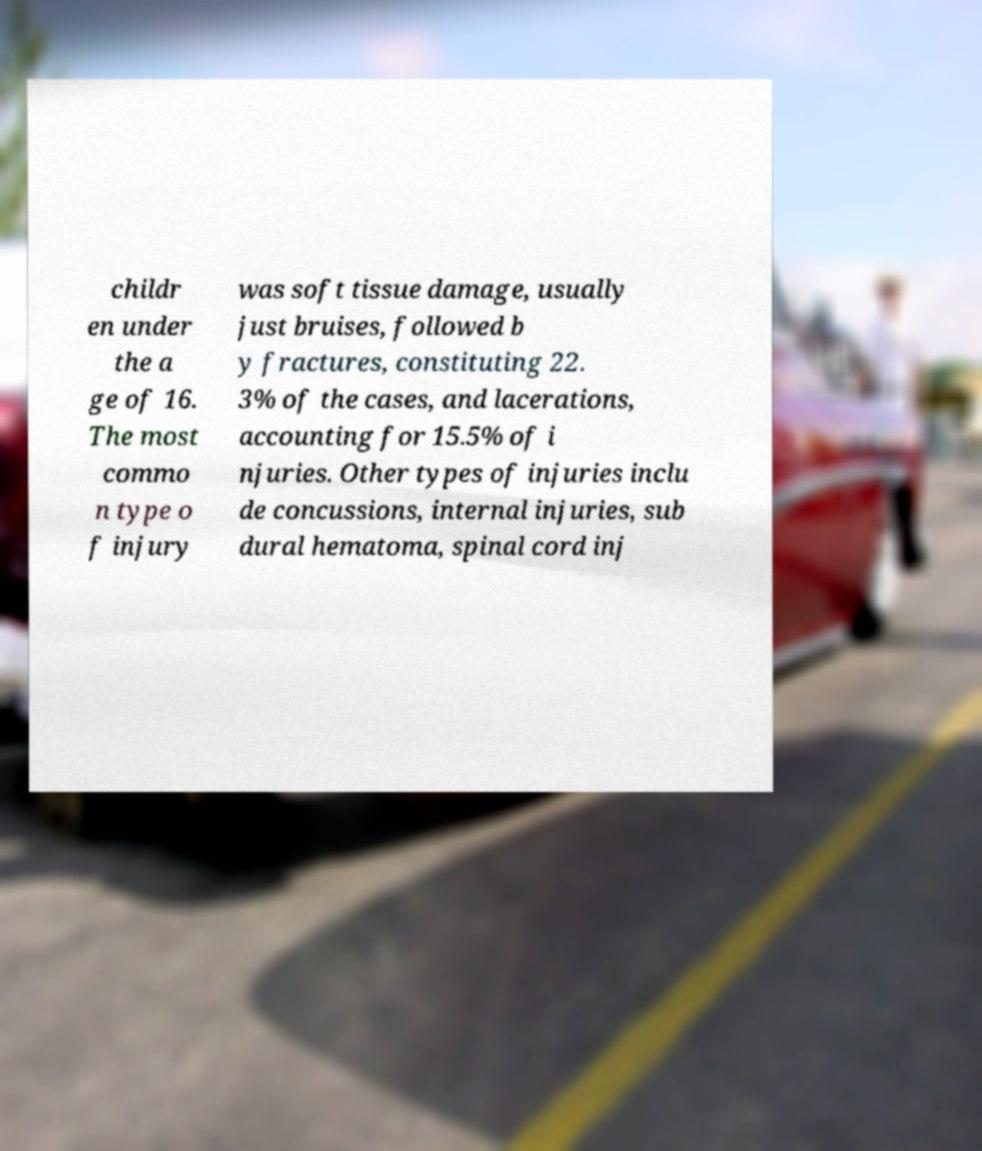I need the written content from this picture converted into text. Can you do that? childr en under the a ge of 16. The most commo n type o f injury was soft tissue damage, usually just bruises, followed b y fractures, constituting 22. 3% of the cases, and lacerations, accounting for 15.5% of i njuries. Other types of injuries inclu de concussions, internal injuries, sub dural hematoma, spinal cord inj 